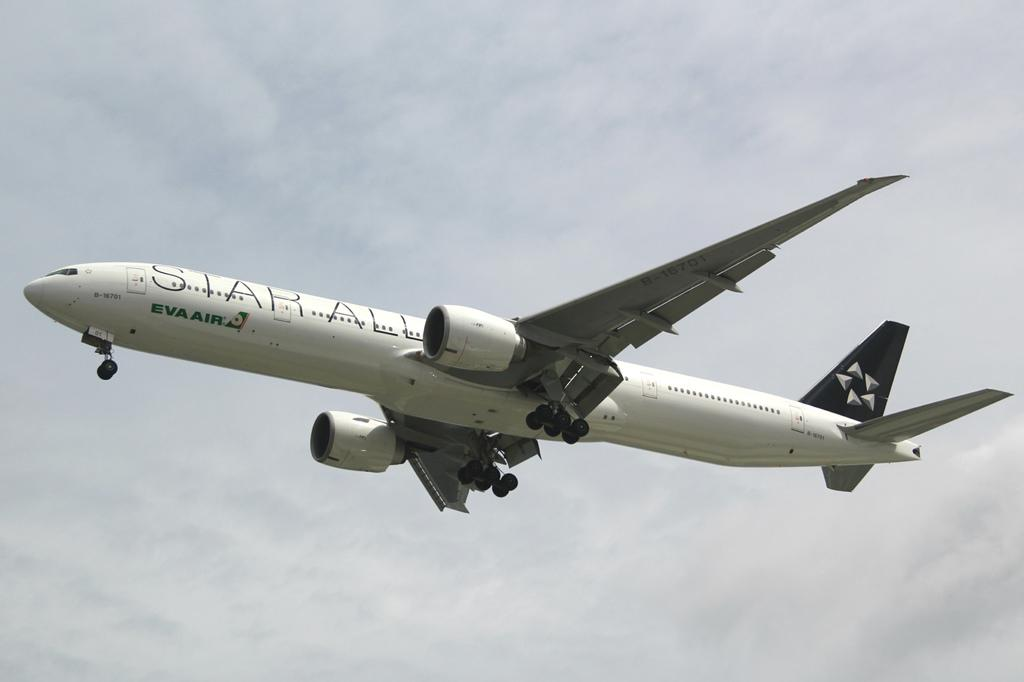What is the main subject of the image? The main subject of the image is an aeroplane. Where is the aeroplane located in the image? The aeroplane is in the air in the image. What can be seen in the background of the image? The sky is visible in the background of the image. What type of food is being served in the lunchroom in the image? There is no lunchroom or food present in the image; it features an aeroplane in the air. What season is depicted in the image, given the presence of falling leaves? There are no leaves, falling or otherwise, present in the image, so it cannot be determined what season is depicted. 